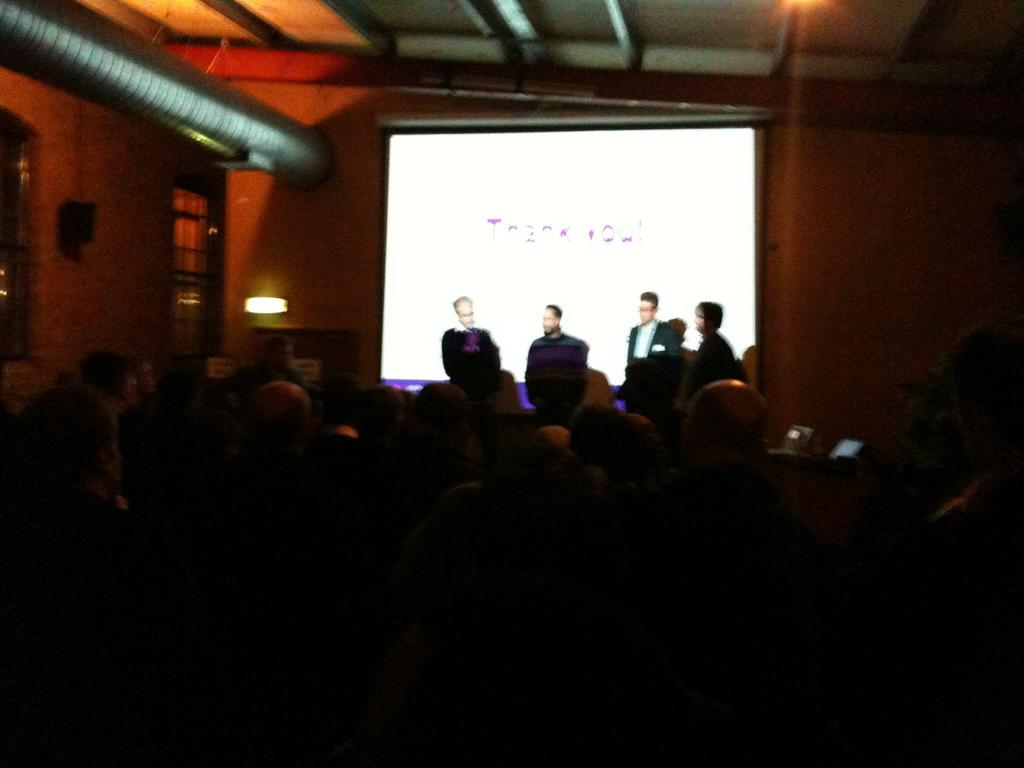Who or what is present in the image? There are people in the image. What objects can be seen on a table in the image? There are laptops on a table in the image. What is visible in the background of the image? There is a screen in the background of the image. Can you describe the lighting in the image? There is a light in the image. What type of structure is present in the image? There is a wall in the image. What type of shade can be seen at the seashore in the image? There is no seashore or shade present in the image. 